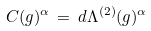Convert formula to latex. <formula><loc_0><loc_0><loc_500><loc_500>C ( g ) ^ { \alpha } \, = \, d \Lambda ^ { ( 2 ) } ( g ) ^ { \alpha }</formula> 